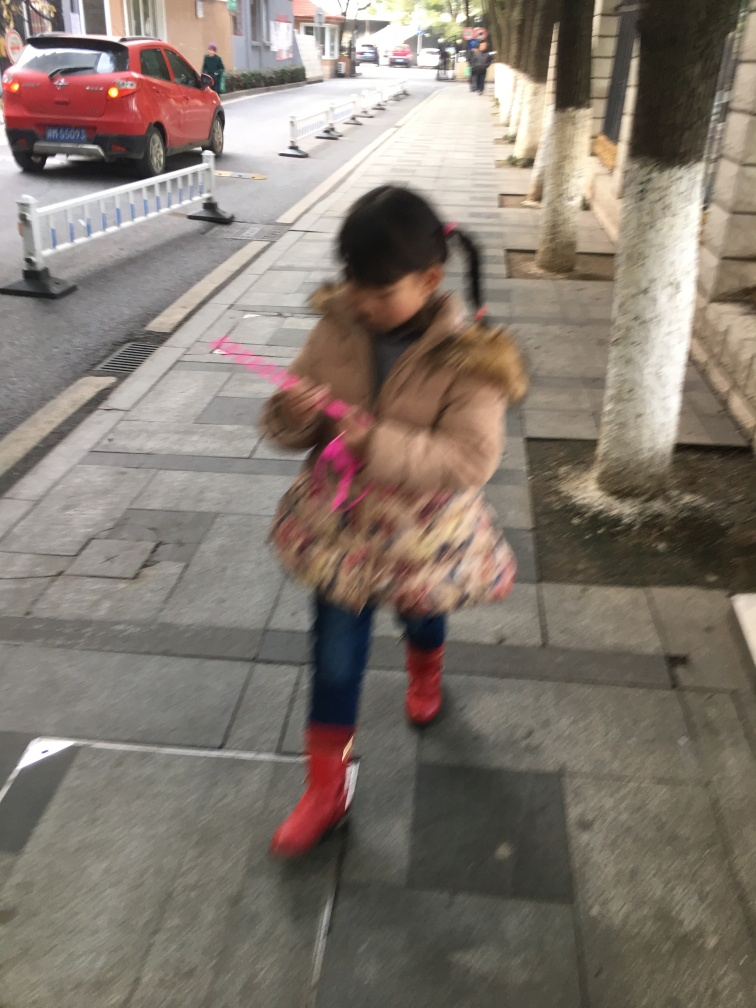Does the image have low sharpness? Yes, the image does exhibit low sharpness. This can be observed by the blurring of the subject, which is a young girl in motion. The lack of clarity in her features and the surrounding environment suggests that the photo was taken with a slow shutter speed, a common cause of image blur, especially when capturing moving objects. 